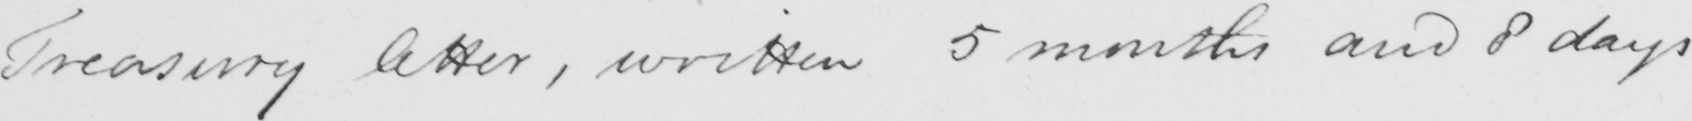Transcribe the text shown in this historical manuscript line. Treasury letter , written 5 months and 8 days 